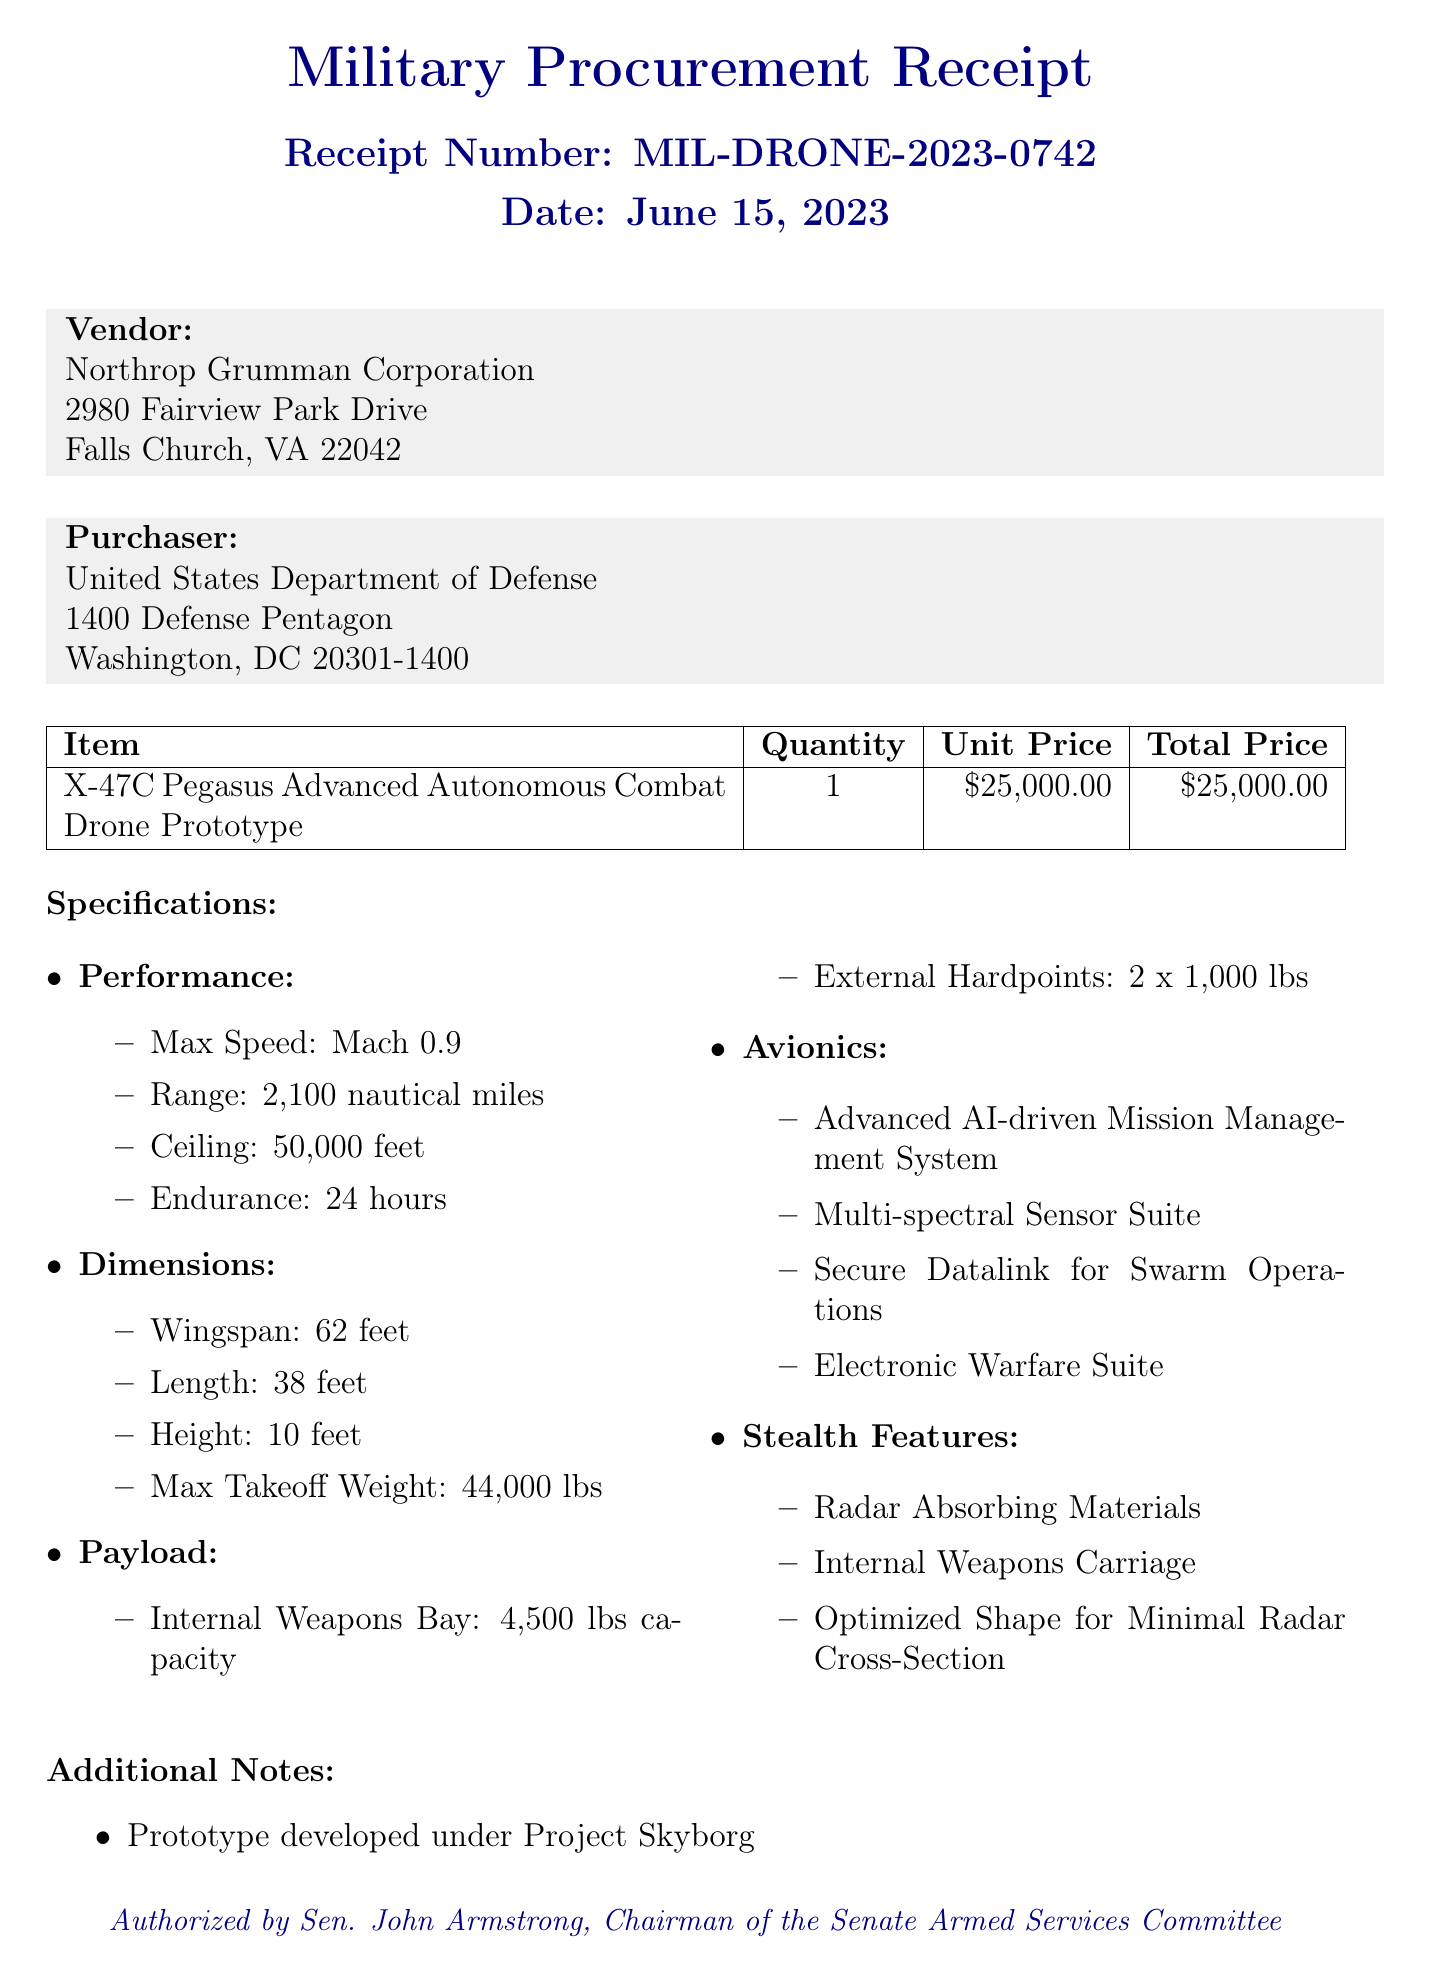What is the receipt number? The receipt number is specifically stated in the document to track the transaction, which is MIL-DRONE-2023-0742.
Answer: MIL-DRONE-2023-0742 Who is the vendor? The vendor is the company that supplied the drone prototype, which is Northrop Grumman Corporation.
Answer: Northrop Grumman Corporation What is the purchase date? The purchase date indicates when the transaction took place, which is June 15, 2023.
Answer: June 15, 2023 What is the total price of the drone prototype? The total price reflects the overall cost for the purchased item, which is $25,000.00.
Answer: $25,000.00 What is the maximum speed of the drone? The maximum speed is a specific performance detail outlined in the specifications, which is Mach 0.9.
Answer: Mach 0.9 How many hardpoints does the drone have? The number of hardpoints refers to the specific external capacity for carrying additional payloads, which is 2.
Answer: 2 What is the project code? The project code is a unique identifier for the research initiative under which the drone was developed, which is DARPA-ACD-2023-47.
Answer: DARPA-ACD-2023-47 What is the funding source for this purchase? The funding source indicates the budget provision used to finance the procurement, specifically FY2023 National Defense Authorization Act, Section 279.
Answer: FY2023 National Defense Authorization Act, Section 279 What military missions is the drone designed for? The document specifies the operational context for which the drone is intended, identified as high-risk penetration missions.
Answer: high-risk penetration missions 